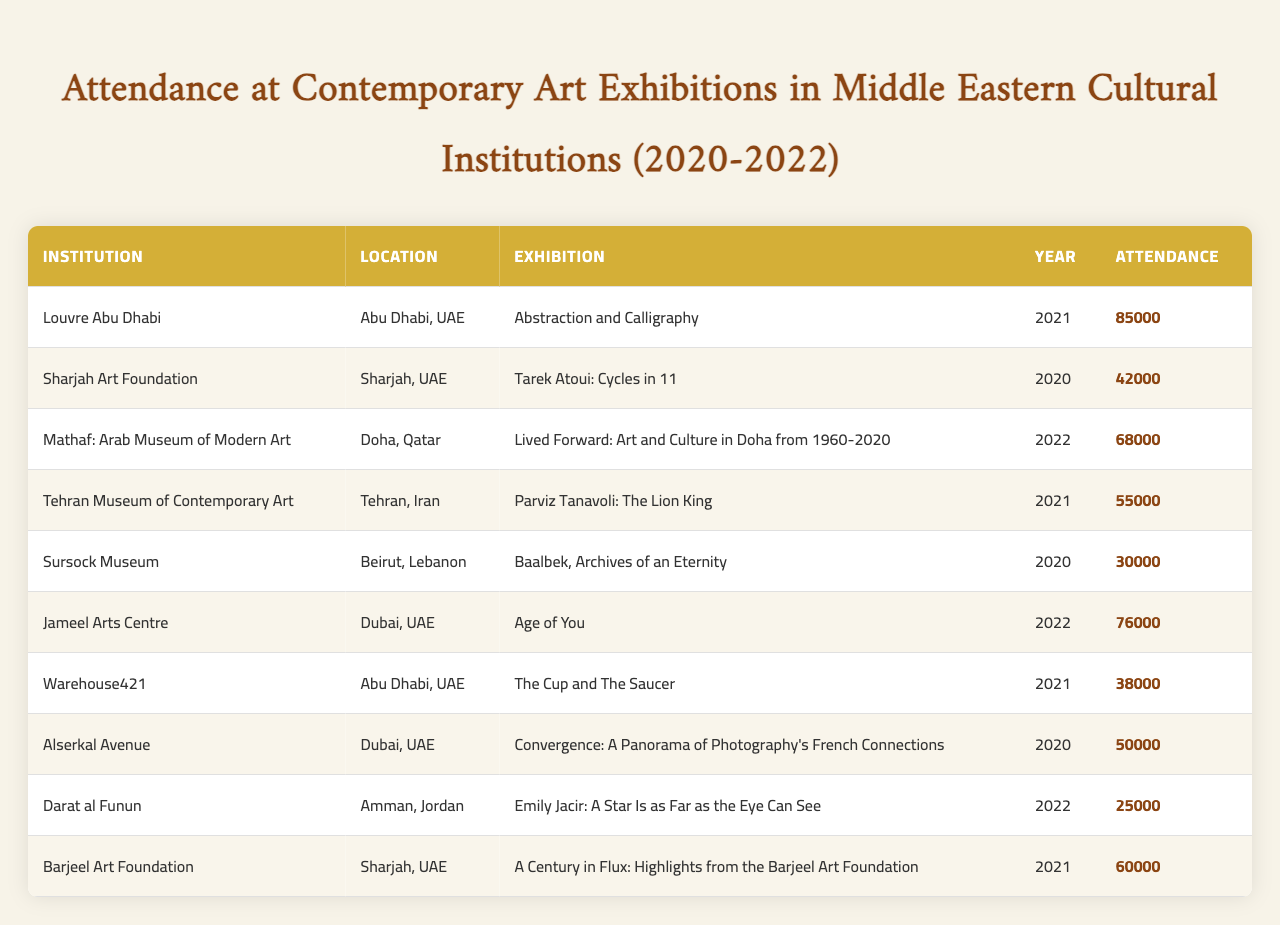What is the exhibition with the highest attendance in 2021? From the table, I look for the exhibitions in the year 2021: "Abstraction and Calligraphy" had 85,000 attendees, and "Parviz Tanavoli: The Lion King" had 55,000 attendees. The highest attendance is from "Abstraction and Calligraphy."
Answer: Abstraction and Calligraphy Which institution had the lowest attendance in the dataset? I’ll review the attendance figures for all institutions. The lowest attendance figure is 25,000, which corresponds to "Emily Jacir: A Star Is as Far as the Eye Can See" at Darat al Funun.
Answer: Darat al Funun What is the total attendance across all exhibitions in 2020? Total attendance for 2020 includes the exhibitions: "Tarek Atoui: Cycles in 11" with 42,000, "Baalbek, Archives of an Eternity" with 30,000, and "Convergence: A Panorama of Photography's French Connections" with 50,000; summing these yields 42,000 + 30,000 + 50,000 = 122,000.
Answer: 122000 Did the exhibition "Age of You" have more attendees than "Lived Forward"? "Age of You" had 76,000 attendees while "Lived Forward" had 68,000. 76,000 is indeed greater than 68,000, so the statement is true.
Answer: Yes What was the average attendance for exhibitions held in Dubai during this period? The exhibitions in Dubai are "Age of You" with 76,000 and "Convergence: A Panorama of Photography's French Connections" with 50,000. The average is computed as (76,000 + 50,000) / 2, which equals 126,000 / 2 = 63,000.
Answer: 63000 How many exhibitions had an attendance of over 60,000? I review the attendance figures: "Abstraction and Calligraphy" (85,000), "Mathaf: Arab Museum of Modern Art" (68,000), "Jameel Arts Centre" (76,000), and "A Century in Flux" (60,000). This leads to 4 exhibitions having figures over 60,000.
Answer: 4 Which city had the highest number of exhibitions listed in the table? By analyzing the table, Abu Dhabi, Dubai, and Sharjah each have 2 exhibitions, while Doha, Tehran, and Amman have 1 each, thus the cities with the highest exhibitions are Abu Dhabi and Dubai with 2 each.
Answer: Abu Dhabi and Dubai 